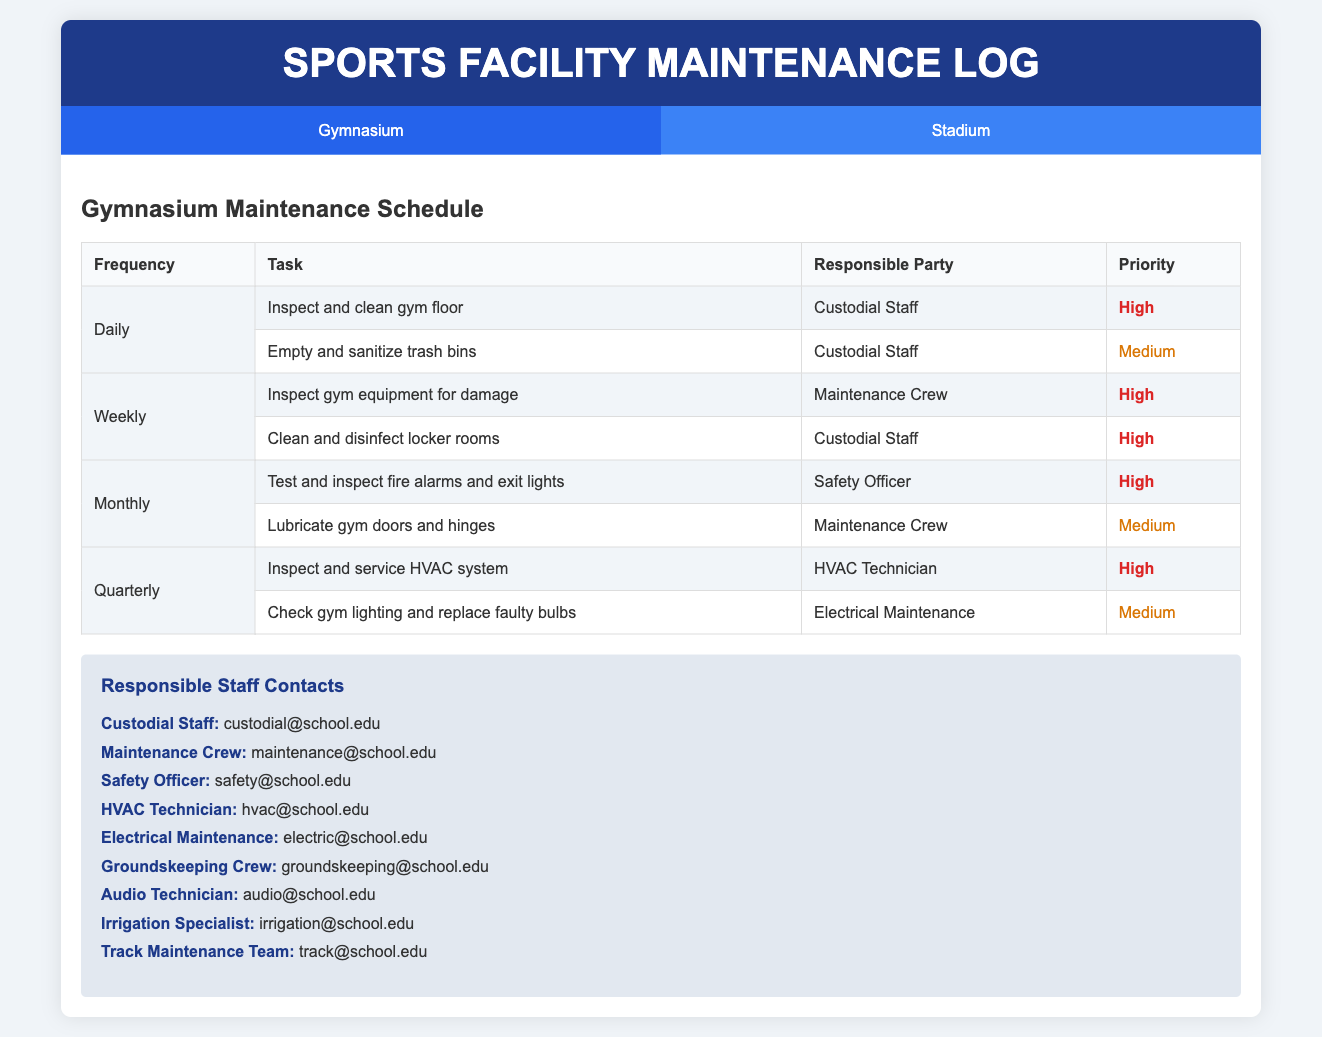What is the highest priority task for the gymnasium? The highest priority task in the gymnasium is inspecting and cleaning the gym floor which is marked as high priority.
Answer: Inspect and clean gym floor How often is the HVAC system inspected in the gymnasium? The HVAC system is inspected quarterly according to the maintenance schedule provided in the document.
Answer: Quarterly Who is responsible for cleaning spectator restrooms in the stadium? The responsible party for cleaning the spectator restrooms in the stadium is the custodial staff, as listed in the maintenance schedule.
Answer: Custodial Staff What is the priority level for lubricating gym doors and hinges? The document states that lubricating gym doors and hinges is marked with a medium priority level.
Answer: Medium How frequently are trash bins emptied and sanitized in the stadium? The trash bins are emptied and sanitized daily in the stadium according to the schedule provided in the document.
Answer: Daily Which technician is responsible for testing and inspecting the PA system? The audio technician is responsible for testing and inspecting the PA system in the stadium as mentioned in the maintenance log.
Answer: Audio Technician What is the priority of inspecting gym equipment for damage? The priority level for inspecting gym equipment for damage is high according to the maintenance log.
Answer: High What contact email should be used for the groundskeeping crew? The email for the groundskeeping crew can be found in the contacts section of the document.
Answer: groundskeeping@school.edu 